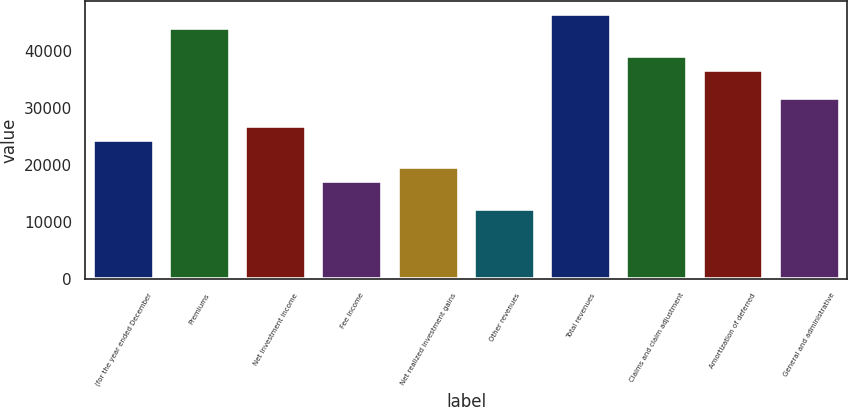<chart> <loc_0><loc_0><loc_500><loc_500><bar_chart><fcel>(for the year ended December<fcel>Premiums<fcel>Net investment income<fcel>Fee income<fcel>Net realized investment gains<fcel>Other revenues<fcel>Total revenues<fcel>Claims and claim adjustment<fcel>Amortization of deferred<fcel>General and administrative<nl><fcel>24477<fcel>44054.8<fcel>26924.2<fcel>17135.4<fcel>19582.6<fcel>12240.9<fcel>46502<fcel>39160.3<fcel>36713.1<fcel>31818.7<nl></chart> 